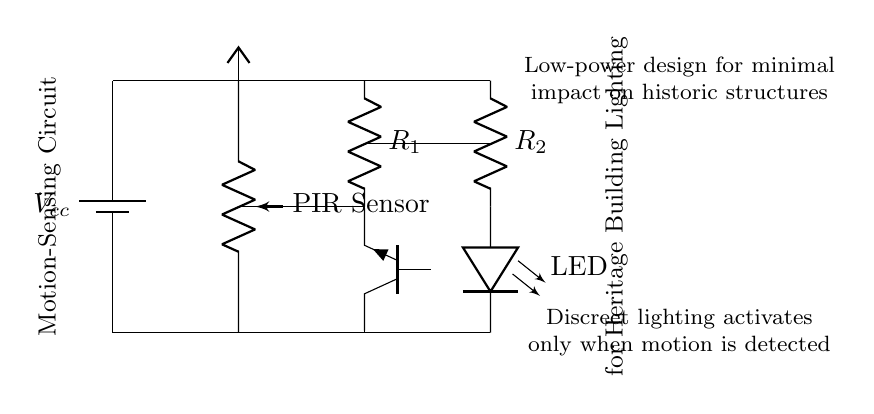What type of sensor is used in this circuit? The circuit includes a PIR sensor, which is identified as the component labeled "PIR Sensor." This sensor is specifically designed to detect motion.
Answer: PIR sensor What are the resistors labeled in the circuit? The resistors are labeled as R1 and R2. They are depicted in the diagram in series with the transistor and LED, indicating their role in regulating current.
Answer: R1 and R2 What is the purpose of the motion-sensing circuit? The circuit's main purpose is to activate discreet lighting when motion is detected, which is indicated by the notes in the diagram stating it activates 'only when motion is detected.'
Answer: Activate discreet lighting How is the power supply represented in the diagram? The power supply is represented by a battery symbol labeled Vcc, providing energy for the entire circuit, which is drawn at the top of the diagram.
Answer: Battery labeled Vcc Which component controls the LED in this circuit? The LED is controlled by the transistor, which is an NPN type, and is responsible for turning the LED on or off based on the signals from the PIR sensor.
Answer: Transistor What is the voltage supply used in this circuit? While the exact voltage isn't provided in the diagram, commonly, Vcc indicates a supply voltage value, which usually is a standard like five volts for such applications, specifically for low power requirements.
Answer: Vcc (commonly 5 volts) How does the circuit minimize impact on historic structures? The circuit is designed to be low-power, which ensures that it does not significantly alter the existing electrical infrastructure of the heritage building, as noted in the comments of the diagram.
Answer: Low-power design 